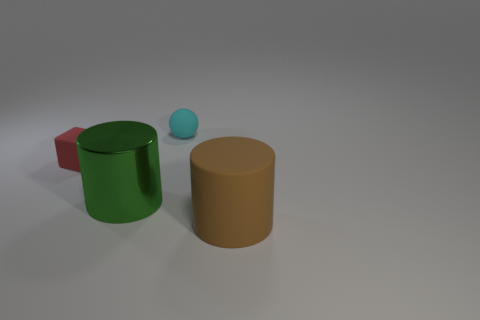Is there a big brown rubber cylinder behind the small thing that is on the left side of the tiny rubber object behind the small red thing?
Your answer should be compact. No. How many other things are there of the same material as the red block?
Offer a terse response. 2. What number of tiny green matte objects are there?
Ensure brevity in your answer.  0. What number of objects are rubber cubes or things behind the red rubber block?
Provide a short and direct response. 2. Are there any other things that are the same shape as the big brown rubber object?
Make the answer very short. Yes. There is a cylinder on the left side of the rubber cylinder; is its size the same as the small red thing?
Provide a succinct answer. No. How many rubber things are blue blocks or brown cylinders?
Offer a terse response. 1. What is the size of the cylinder left of the big brown rubber cylinder?
Provide a succinct answer. Large. Do the green thing and the small red matte object have the same shape?
Offer a terse response. No. What number of tiny things are brown matte cylinders or metal objects?
Your answer should be very brief. 0. 